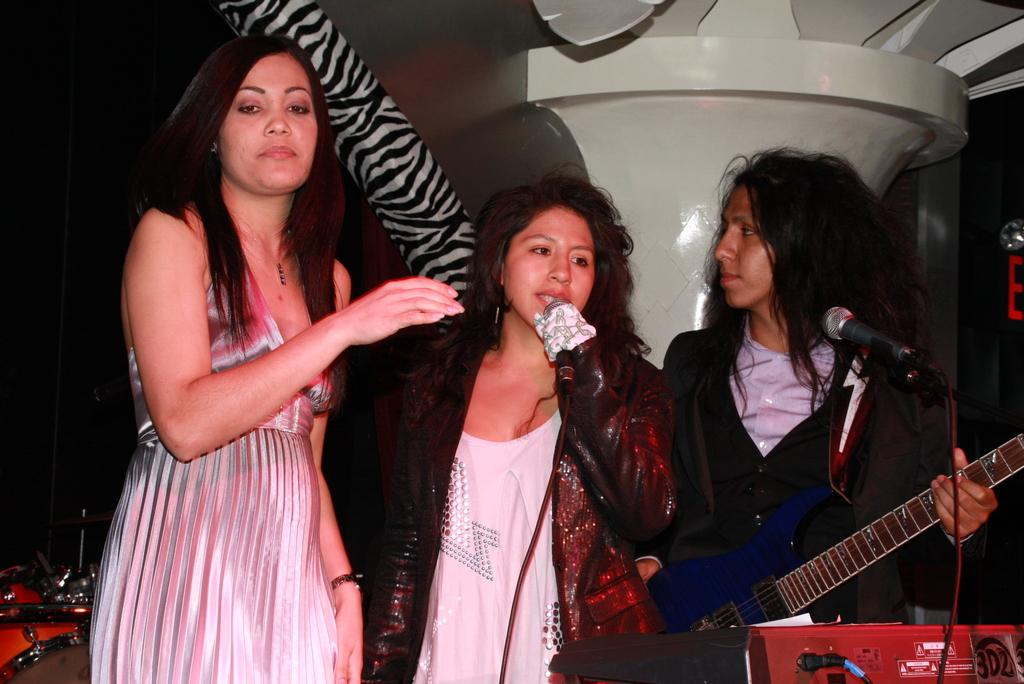How many people are in the image? There are three persons in the image. What are the persons doing in the image? The persons are standing in front of a microphone. What object is one of the persons holding? One of the persons is holding a guitar. Are there any musical instruments visible in the image? Yes, there are musical instruments in the image. What type of can is being used by the persons in the image? There is no can present in the image. Can you see any pets in the image? There are no pets visible in the image. 